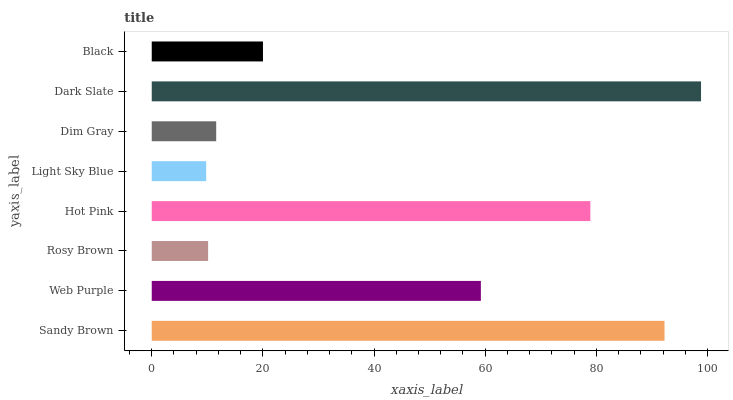Is Light Sky Blue the minimum?
Answer yes or no. Yes. Is Dark Slate the maximum?
Answer yes or no. Yes. Is Web Purple the minimum?
Answer yes or no. No. Is Web Purple the maximum?
Answer yes or no. No. Is Sandy Brown greater than Web Purple?
Answer yes or no. Yes. Is Web Purple less than Sandy Brown?
Answer yes or no. Yes. Is Web Purple greater than Sandy Brown?
Answer yes or no. No. Is Sandy Brown less than Web Purple?
Answer yes or no. No. Is Web Purple the high median?
Answer yes or no. Yes. Is Black the low median?
Answer yes or no. Yes. Is Light Sky Blue the high median?
Answer yes or no. No. Is Hot Pink the low median?
Answer yes or no. No. 